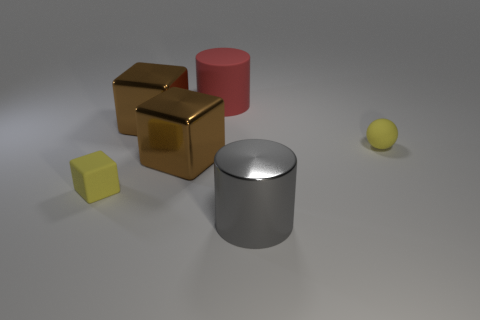How many things are things to the left of the gray cylinder or tiny things?
Provide a short and direct response. 5. Is there a big brown metal block?
Ensure brevity in your answer.  Yes. There is a thing that is right of the large matte thing and in front of the matte sphere; what is its shape?
Provide a short and direct response. Cylinder. There is a matte cylinder that is behind the big metal cylinder; what is its size?
Your response must be concise. Large. Is the color of the tiny thing behind the small matte cube the same as the matte cylinder?
Ensure brevity in your answer.  No. How many tiny yellow objects are the same shape as the big gray object?
Offer a terse response. 0. What number of objects are big things that are on the left side of the red rubber cylinder or tiny objects right of the small rubber cube?
Make the answer very short. 3. What number of green objects are either small balls or small rubber cubes?
Your answer should be very brief. 0. There is a big object that is both behind the sphere and left of the big red cylinder; what material is it?
Make the answer very short. Metal. Do the red thing and the tiny yellow block have the same material?
Give a very brief answer. Yes. 